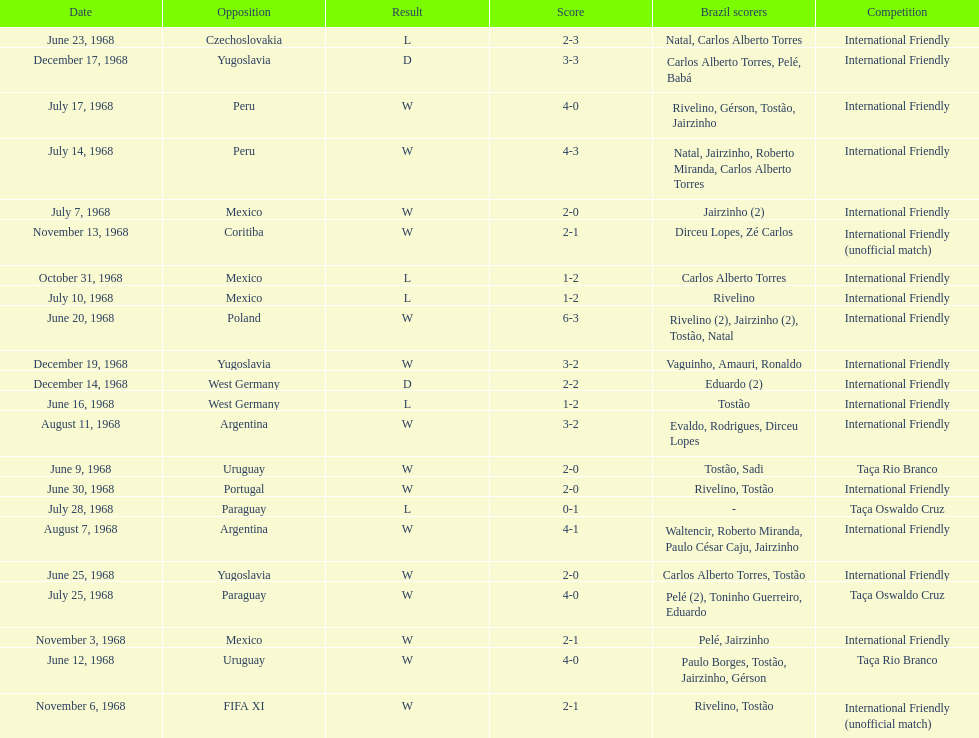How many matches are wins? 15. 